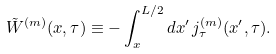<formula> <loc_0><loc_0><loc_500><loc_500>\tilde { W } ^ { ( m ) } ( x , \tau ) \equiv - \int _ { x } ^ { L / 2 } d x ^ { \prime } \, j _ { \tau } ^ { ( m ) } ( x ^ { \prime } , \tau ) .</formula> 